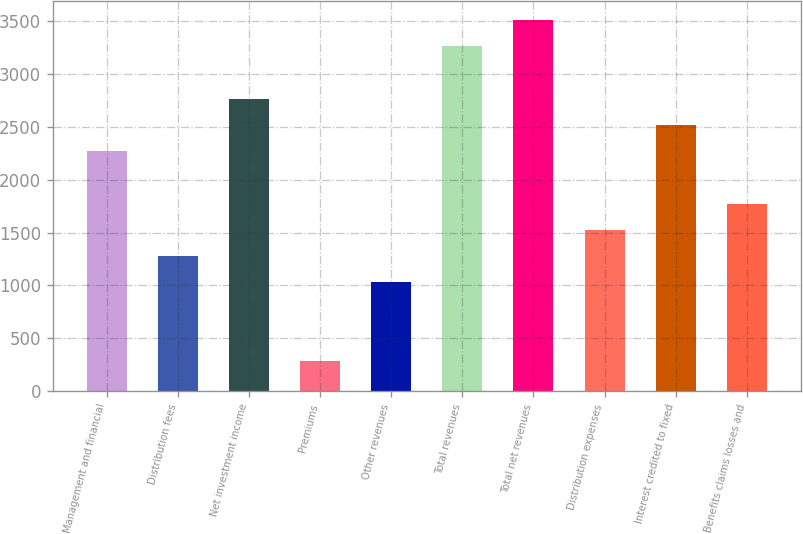<chart> <loc_0><loc_0><loc_500><loc_500><bar_chart><fcel>Management and financial<fcel>Distribution fees<fcel>Net investment income<fcel>Premiums<fcel>Other revenues<fcel>Total revenues<fcel>Total net revenues<fcel>Distribution expenses<fcel>Interest credited to fixed<fcel>Benefits claims losses and<nl><fcel>2270.5<fcel>1276.5<fcel>2767.5<fcel>282.5<fcel>1028<fcel>3264.5<fcel>3513<fcel>1525<fcel>2519<fcel>1773.5<nl></chart> 